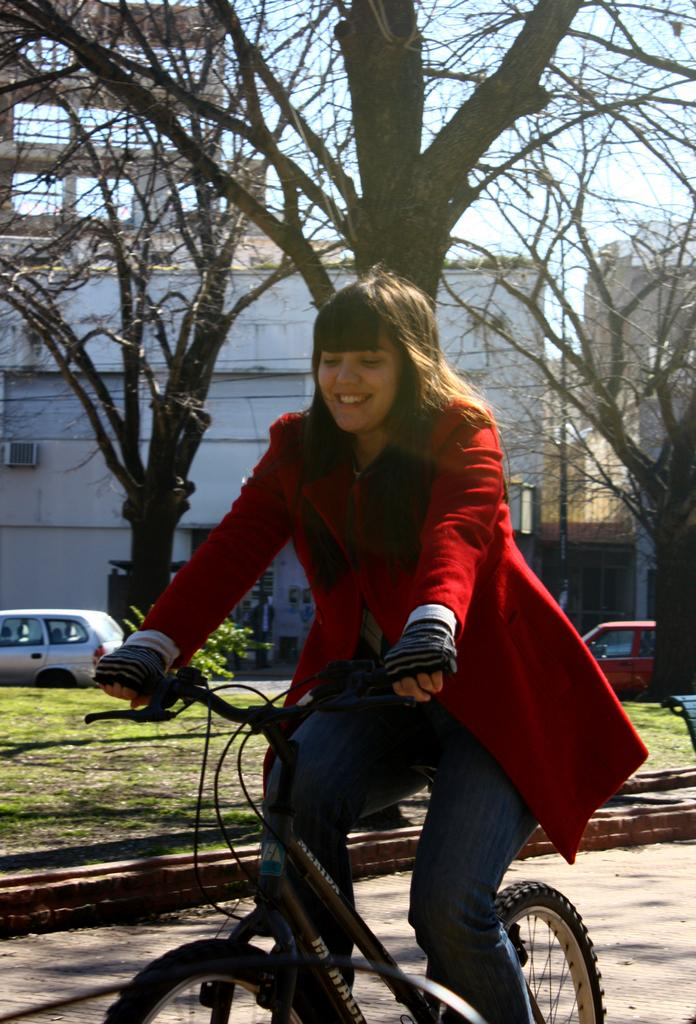Who is the main subject in the image? There is a woman in the image. What is the woman doing in the image? The woman is sitting on a bicycle. What type of natural environment can be seen in the image? There are trees visible in the image. What type of man-made structure can be seen in the image? There is a building in the image. What type of beast is the woman riding in the image? There is no beast present in the image; the woman is sitting on a bicycle. What selection of items is the woman holding in the image? The image does not show the woman holding any items, so it cannot be determined what selection she might have. 